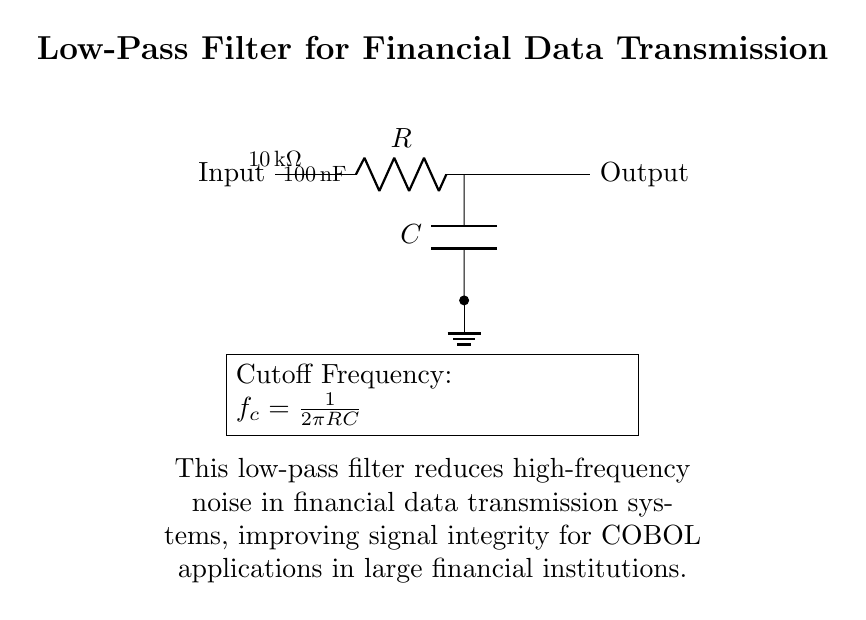What is the resistance value in this circuit? The resistance value in the circuit is specified as ten thousand ohms, labeled directly on the resistor symbol.
Answer: ten thousand ohms What is the capacitance value in this circuit? The circuit indicates that the capacitance value is one hundred nanofarads, which is also labeled on the capacitor symbol.
Answer: one hundred nanofarads What is the purpose of the low-pass filter in this circuit? The low-pass filter is designed to reduce high-frequency noise, thereby improving the integrity of financial data signals transmitted through the system.
Answer: reduce high-frequency noise What is the cutoff frequency formula shown in the circuit? The formula for calculating the cutoff frequency, prominently displayed, is one over two pi times the resistance times the capacitance.
Answer: one over two pi RC How does increasing the resistor value affect the cutoff frequency? Increasing the resistor value lowers the cutoff frequency, since the formula shows that the cutoff frequency is inversely proportional to the resistance value. Thus, a higher resistance results in a smaller frequency.
Answer: lowers cutoff frequency What is the relationship between resistance and capacitance for this filter? The relationship is that the product of resistance and capacitance determines the cutoff frequency; as either increases, the cutoff frequency decreases, making the filter more effective at blocking higher frequencies.
Answer: inversely related What type of filter is represented in this circuit? This circuit represents a low-pass filter, indicated by its design and purpose of allowing low frequencies to pass while attenuating higher frequencies.
Answer: low-pass filter 